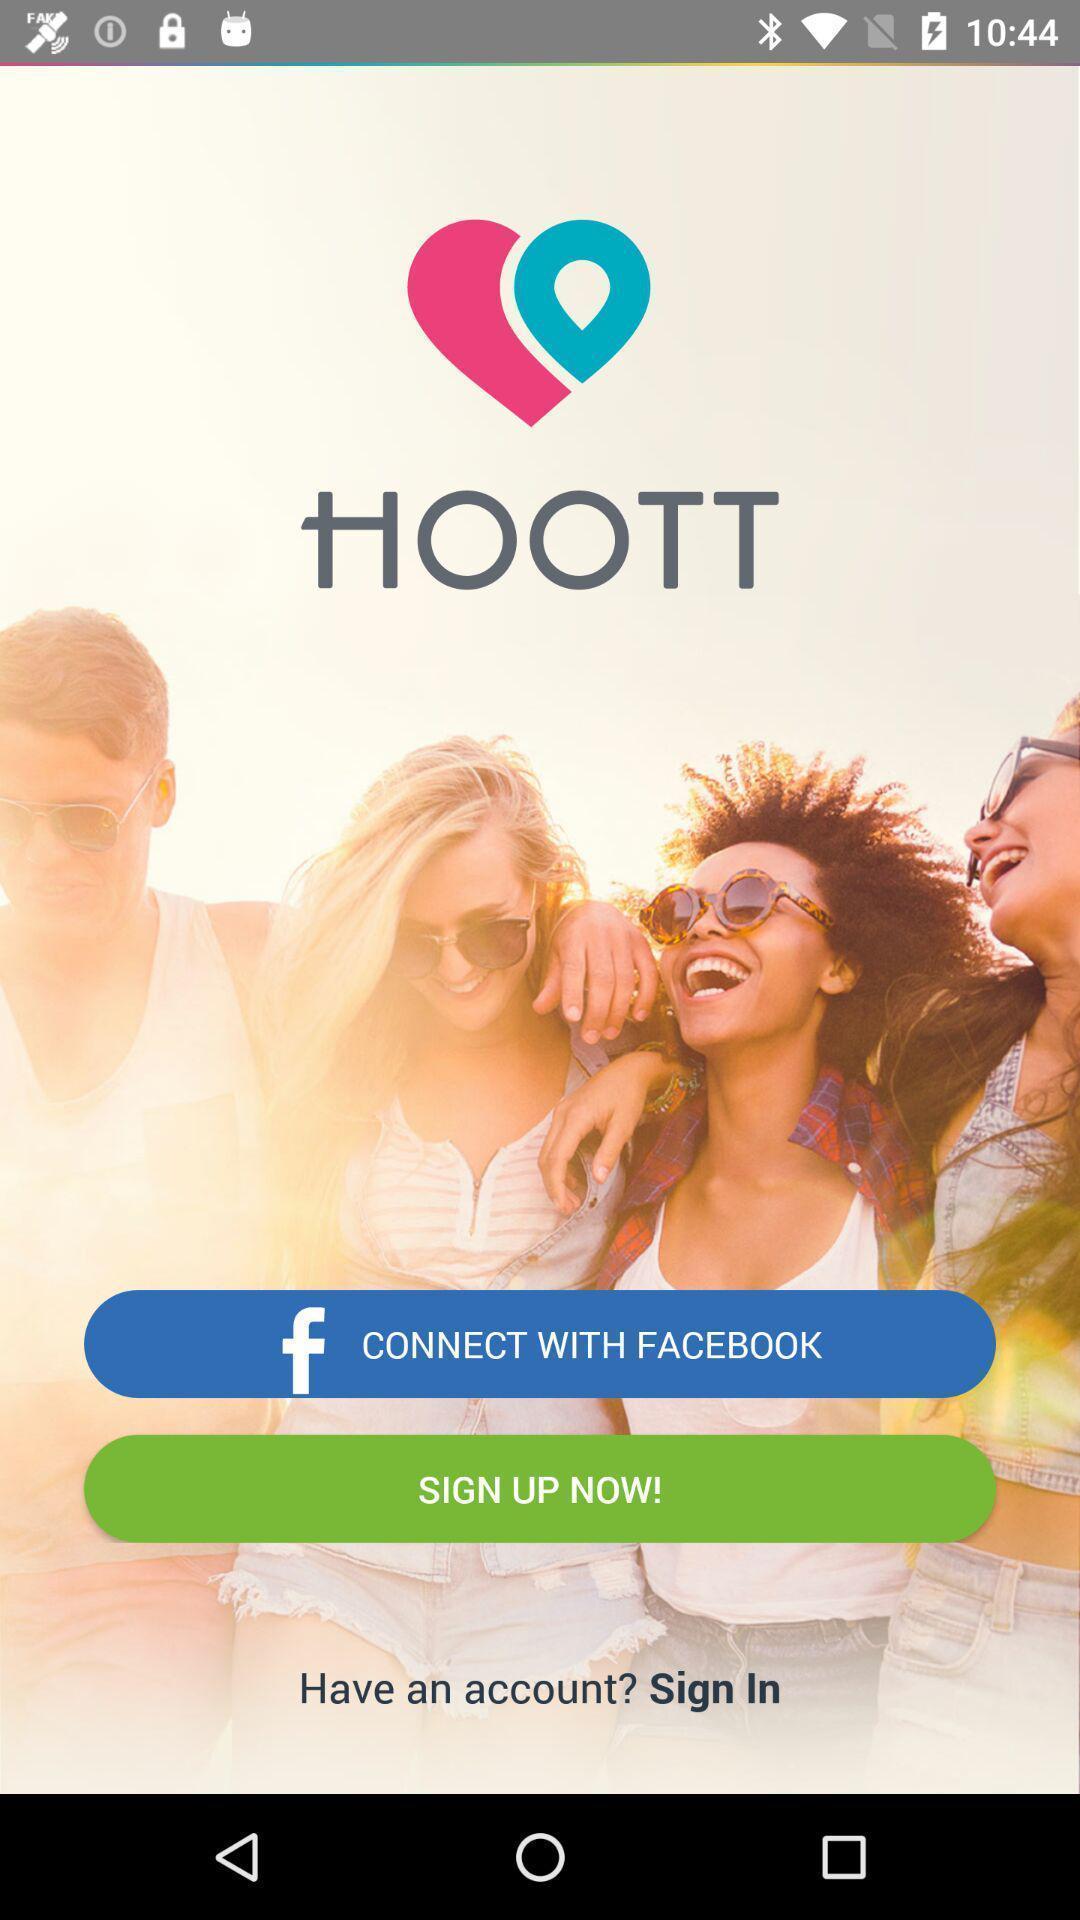Provide a textual representation of this image. Starting page. 